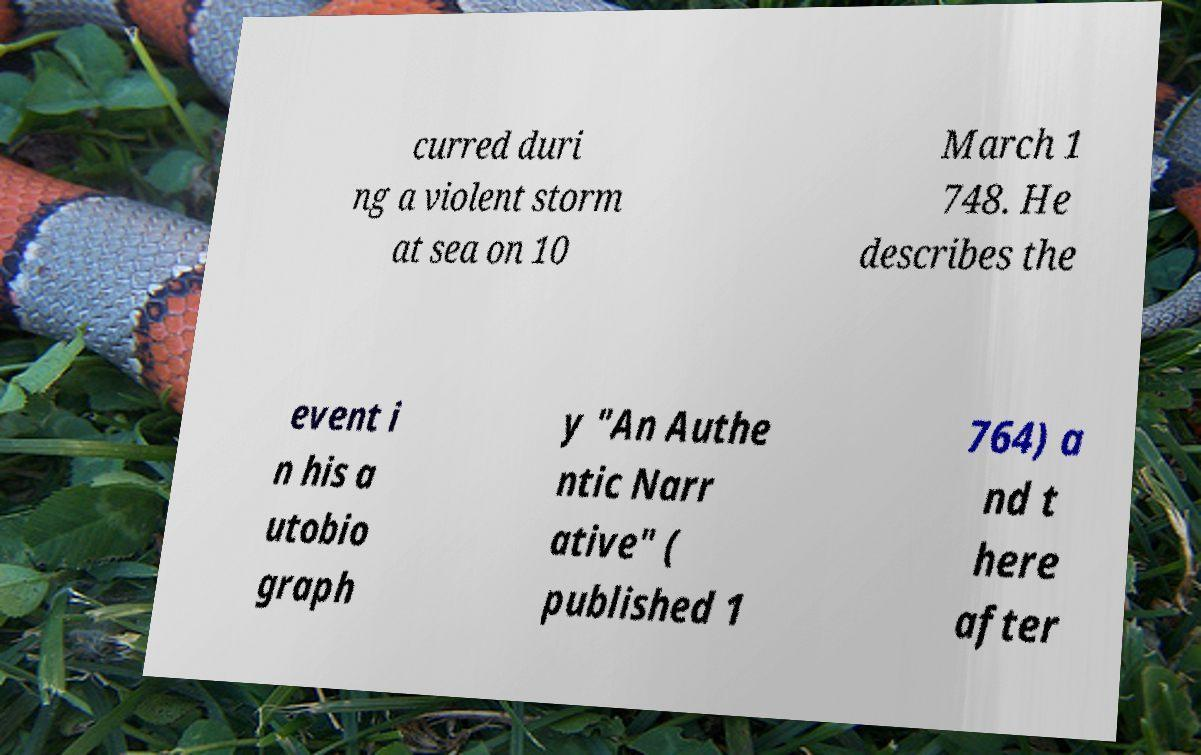I need the written content from this picture converted into text. Can you do that? curred duri ng a violent storm at sea on 10 March 1 748. He describes the event i n his a utobio graph y "An Authe ntic Narr ative" ( published 1 764) a nd t here after 